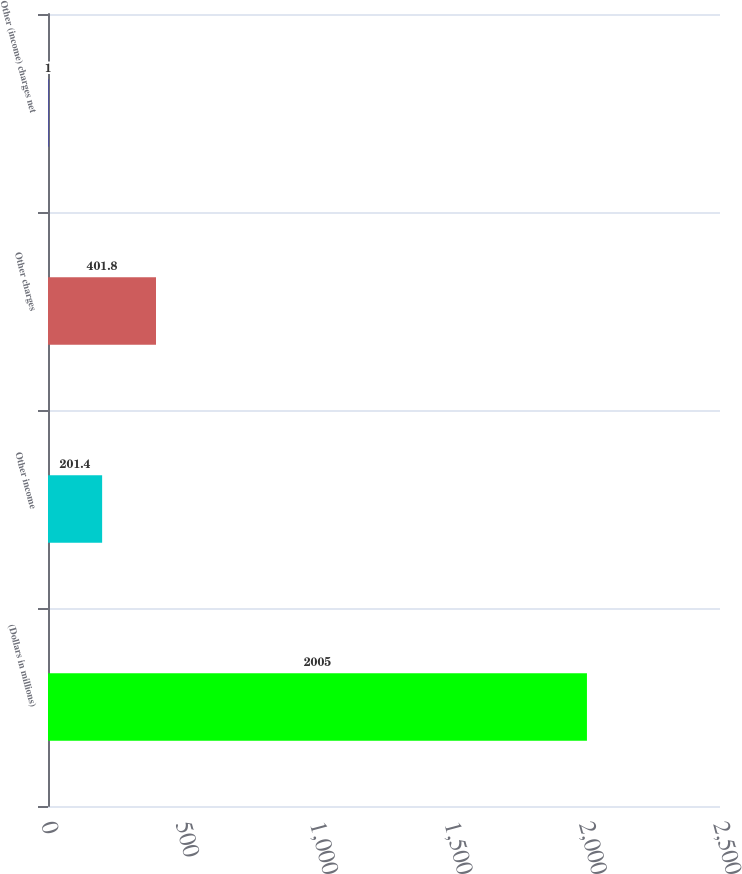Convert chart to OTSL. <chart><loc_0><loc_0><loc_500><loc_500><bar_chart><fcel>(Dollars in millions)<fcel>Other income<fcel>Other charges<fcel>Other (income) charges net<nl><fcel>2005<fcel>201.4<fcel>401.8<fcel>1<nl></chart> 